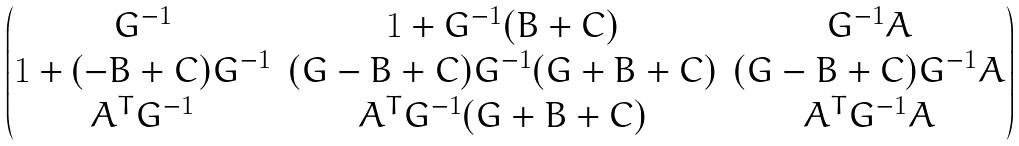Convert formula to latex. <formula><loc_0><loc_0><loc_500><loc_500>\begin{pmatrix} G ^ { - 1 } & 1 + G ^ { - 1 } ( B + C ) & G ^ { - 1 } A \\ 1 + ( - B + C ) G ^ { - 1 } & ( G - B + C ) G ^ { - 1 } ( G + B + C ) & ( G - B + C ) G ^ { - 1 } A \\ A ^ { T } G ^ { - 1 } & A ^ { T } G ^ { - 1 } ( G + B + C ) & A ^ { T } G ^ { - 1 } A \end{pmatrix}</formula> 